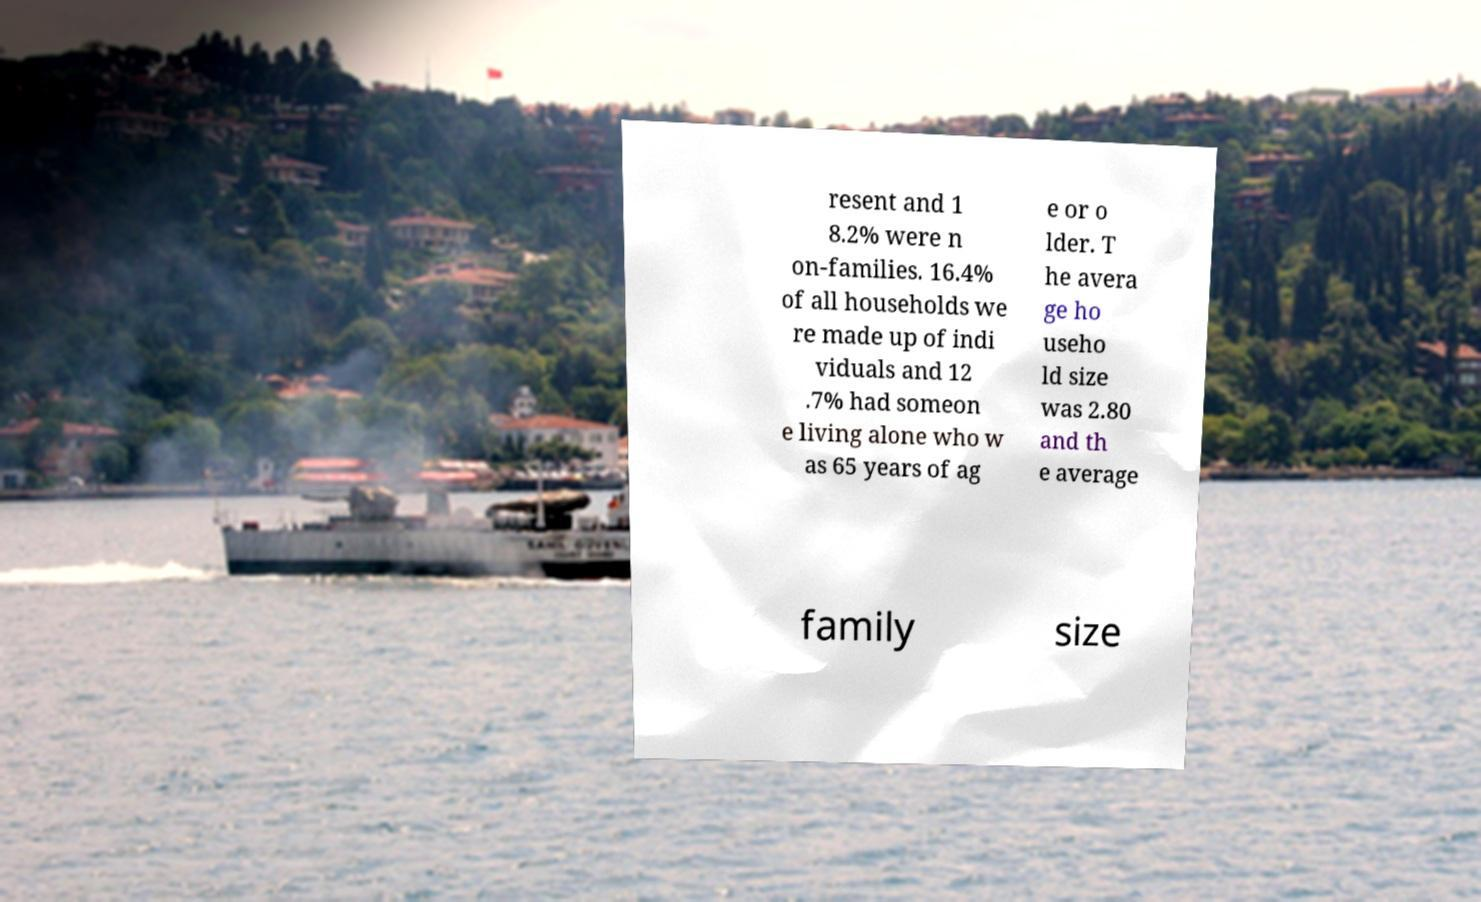Please identify and transcribe the text found in this image. resent and 1 8.2% were n on-families. 16.4% of all households we re made up of indi viduals and 12 .7% had someon e living alone who w as 65 years of ag e or o lder. T he avera ge ho useho ld size was 2.80 and th e average family size 